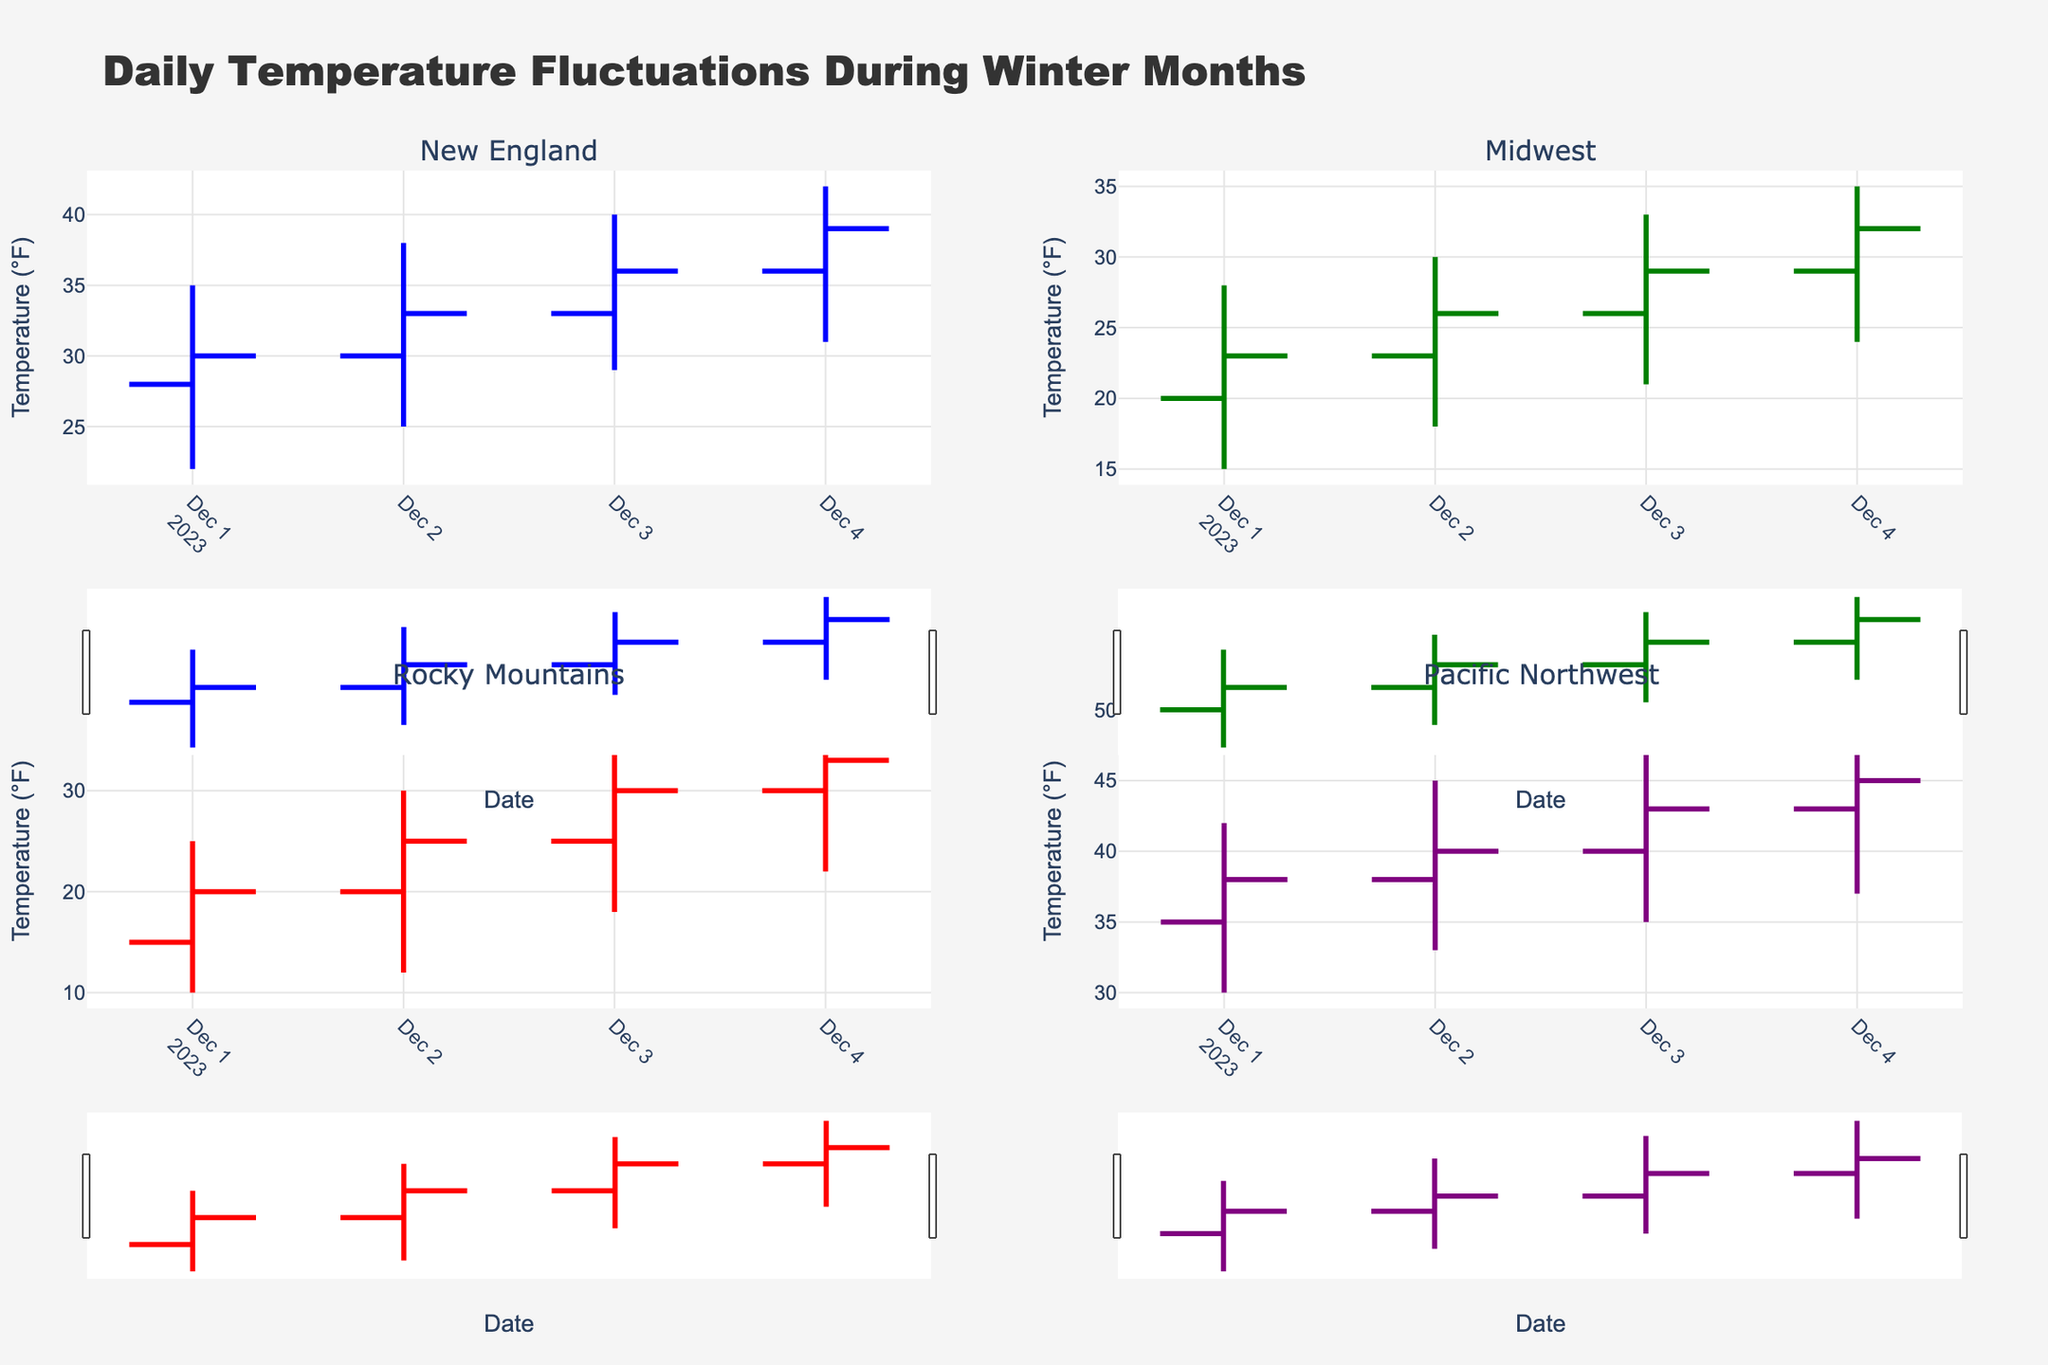What's the title of the figure? The title of the figure is usually displayed prominently at the top of the chart. In this figure, the title text is 'Daily Temperature Fluctuations During Winter Months'.
Answer: Daily Temperature Fluctuations During Winter Months What are the four regions shown in the figure? The figure contains four subplots, each representing a different region. The subplot titles are 'New England', 'Midwest', 'Rocky Mountains', and 'Pacific Northwest'.
Answer: New England, Midwest, Rocky Mountains, Pacific Northwest On December 3rd, which region had the highest temperature and what was the value? By observing the 'High' values on December 3rd in each subplot, we identify the region with the highest recorded temperature. The 'Pacific Northwest' region had a high of 48°F on December 3rd.
Answer: Pacific Northwest, 48°F Which region had the lowest opening temperature on December 1st? To find the lowest opening temperature on December 1st, we compare the 'Open' values of all regions on that date. The 'Rocky Mountains' region had the lowest opening temperature with 15°F.
Answer: Rocky Mountains How did the closing temperatures change in the New England region from December 1st to December 4th? We track the 'Close' values for the New England region from December 1st to December 4th: 30°F on the 1st, 33°F on the 2nd, 36°F on the 3rd, and 39°F on the 4th. The closing temperatures show a consistent upward trend.
Answer: Increased each day What was the range of temperatures in the Midwest region on December 4th? The range is calculated by subtracting the 'Low' value from the 'High' value for the Midwest region on December 4th. The range on December 4th is (35°F - 24°F) = 11°F.
Answer: 11°F For the Rocky Mountains, compare the high temperatures on December 1st and December 4th. We observe the 'High' values in the Rocky Mountains subplot on December 1st and December 4th. The high temperature increased from 25°F on December 1st to 38°F on December 4th.
Answer: Increased by 13°F Which region showed the least variation in daily temperatures on December 2nd? Variation is determined by the difference between 'High' and 'Low' values on December 2nd for each region. Least variation (difference) is found in 'Pacific Northwest' with (45°F - 33°F) = 12°F.
Answer: Pacific Northwest Calculate the average closing temperature for the Midwest region from December 1st to December 4th. To find the average, sum the 'Close' values for the Midwest (23°F + 26°F + 29°F + 32°F) = 110°F, then divide by the number of days (4). The average closing temperature is 110°F / 4 = 27.5°F.
Answer: 27.5°F What was the highest recorded low temperature in any region during the given dates? By examining the 'Low' values across all regions and dates, the highest recorded low temperature was 37°F in the 'Pacific Northwest' on December 4th.
Answer: 37°F 